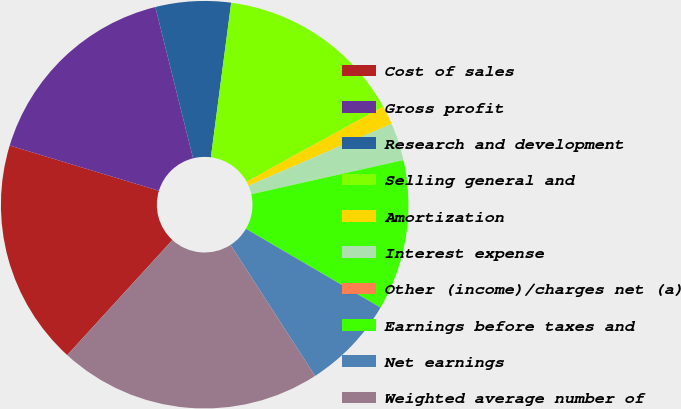<chart> <loc_0><loc_0><loc_500><loc_500><pie_chart><fcel>Cost of sales<fcel>Gross profit<fcel>Research and development<fcel>Selling general and<fcel>Amortization<fcel>Interest expense<fcel>Other (income)/charges net (a)<fcel>Earnings before taxes and<fcel>Net earnings<fcel>Weighted average number of<nl><fcel>17.91%<fcel>16.42%<fcel>5.97%<fcel>14.93%<fcel>1.49%<fcel>2.99%<fcel>0.0%<fcel>11.94%<fcel>7.46%<fcel>20.9%<nl></chart> 